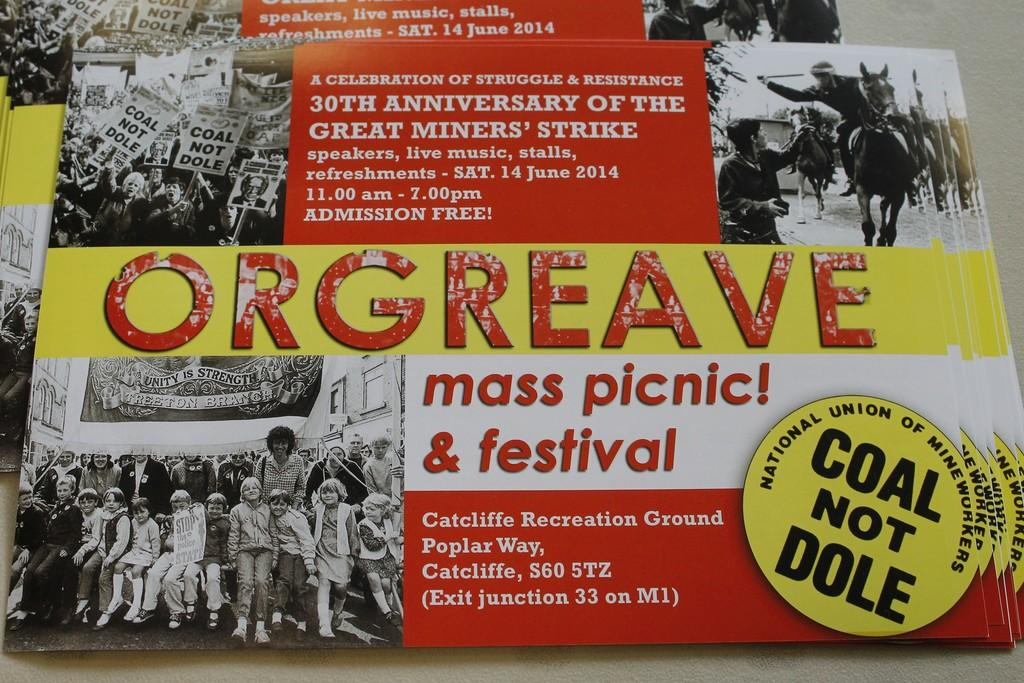<image>
Relay a brief, clear account of the picture shown. A stack of post cards advertising Orgreave mass picnic and festival in celebration of the Great miners' strike. 